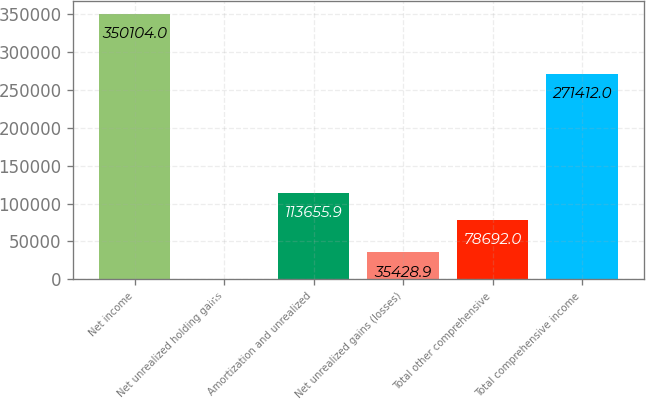Convert chart to OTSL. <chart><loc_0><loc_0><loc_500><loc_500><bar_chart><fcel>Net income<fcel>Net unrealized holding gains<fcel>Amortization and unrealized<fcel>Net unrealized gains (losses)<fcel>Total other comprehensive<fcel>Total comprehensive income<nl><fcel>350104<fcel>465<fcel>113656<fcel>35428.9<fcel>78692<fcel>271412<nl></chart> 